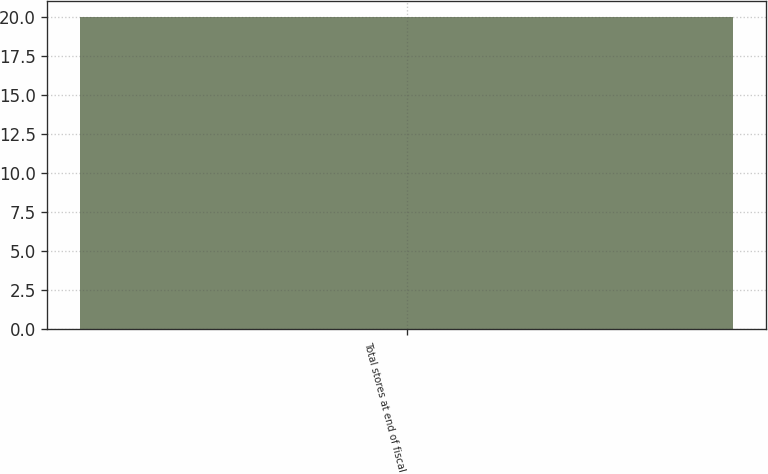<chart> <loc_0><loc_0><loc_500><loc_500><bar_chart><fcel>Total stores at end of fiscal<nl><fcel>20<nl></chart> 